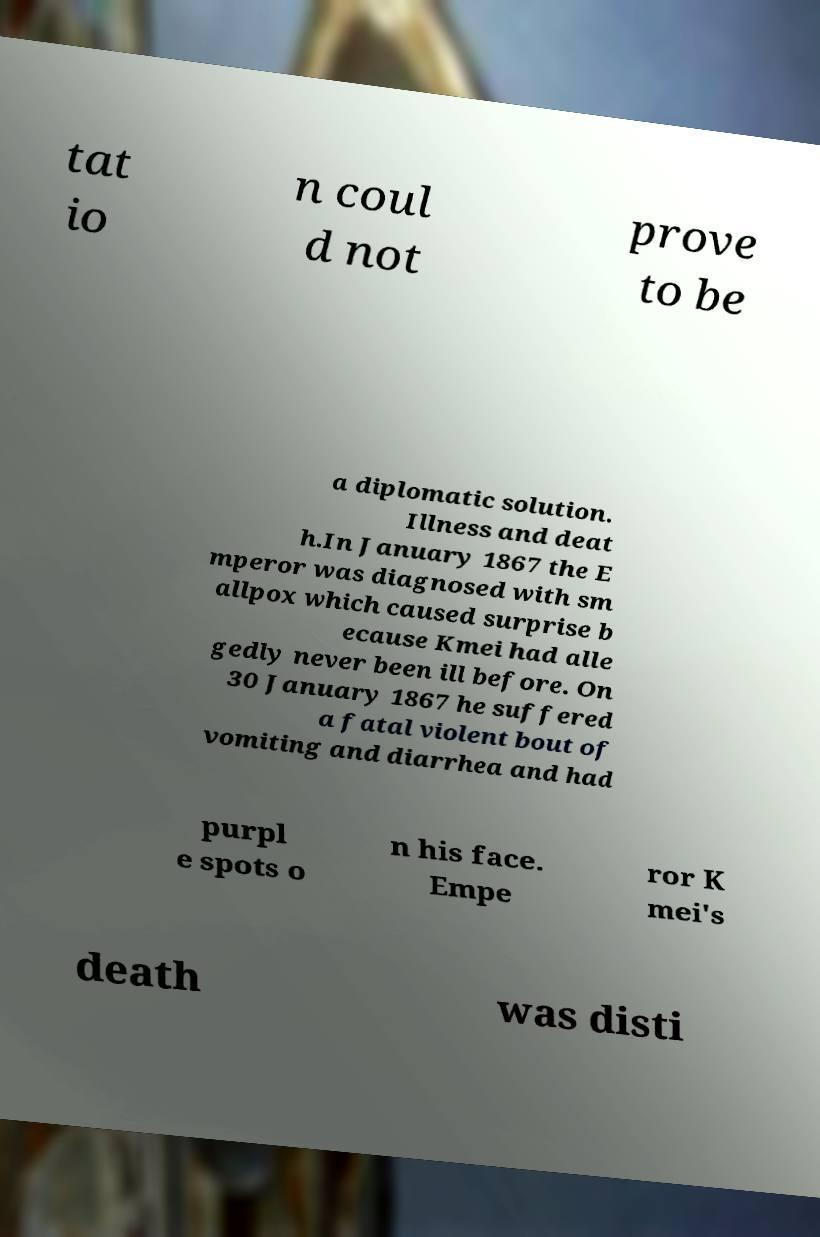For documentation purposes, I need the text within this image transcribed. Could you provide that? tat io n coul d not prove to be a diplomatic solution. Illness and deat h.In January 1867 the E mperor was diagnosed with sm allpox which caused surprise b ecause Kmei had alle gedly never been ill before. On 30 January 1867 he suffered a fatal violent bout of vomiting and diarrhea and had purpl e spots o n his face. Empe ror K mei's death was disti 